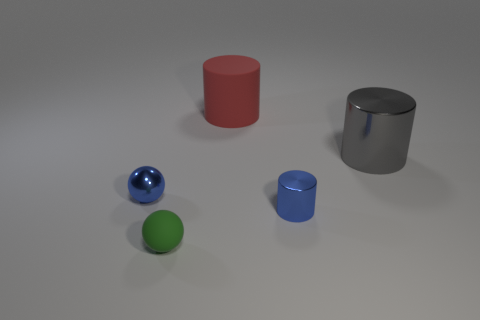There is a metallic object that is the same color as the tiny cylinder; what is its shape?
Provide a short and direct response. Sphere. Are there more small yellow cylinders than big gray shiny cylinders?
Offer a terse response. No. What is the color of the small thing that is on the right side of the rubber thing that is in front of the object that is behind the big gray metal cylinder?
Make the answer very short. Blue. There is a metal object right of the blue metallic cylinder; is its shape the same as the green object?
Make the answer very short. No. There is a shiny object that is the same size as the red rubber object; what color is it?
Offer a terse response. Gray. What number of small gray matte spheres are there?
Offer a terse response. 0. Does the large thing that is in front of the rubber cylinder have the same material as the green ball?
Your answer should be very brief. No. There is a thing that is both in front of the tiny blue shiny ball and right of the tiny green matte thing; what material is it made of?
Offer a very short reply. Metal. What size is the thing that is the same color as the tiny cylinder?
Offer a terse response. Small. What is the material of the large object that is left of the thing to the right of the blue metallic cylinder?
Provide a short and direct response. Rubber. 